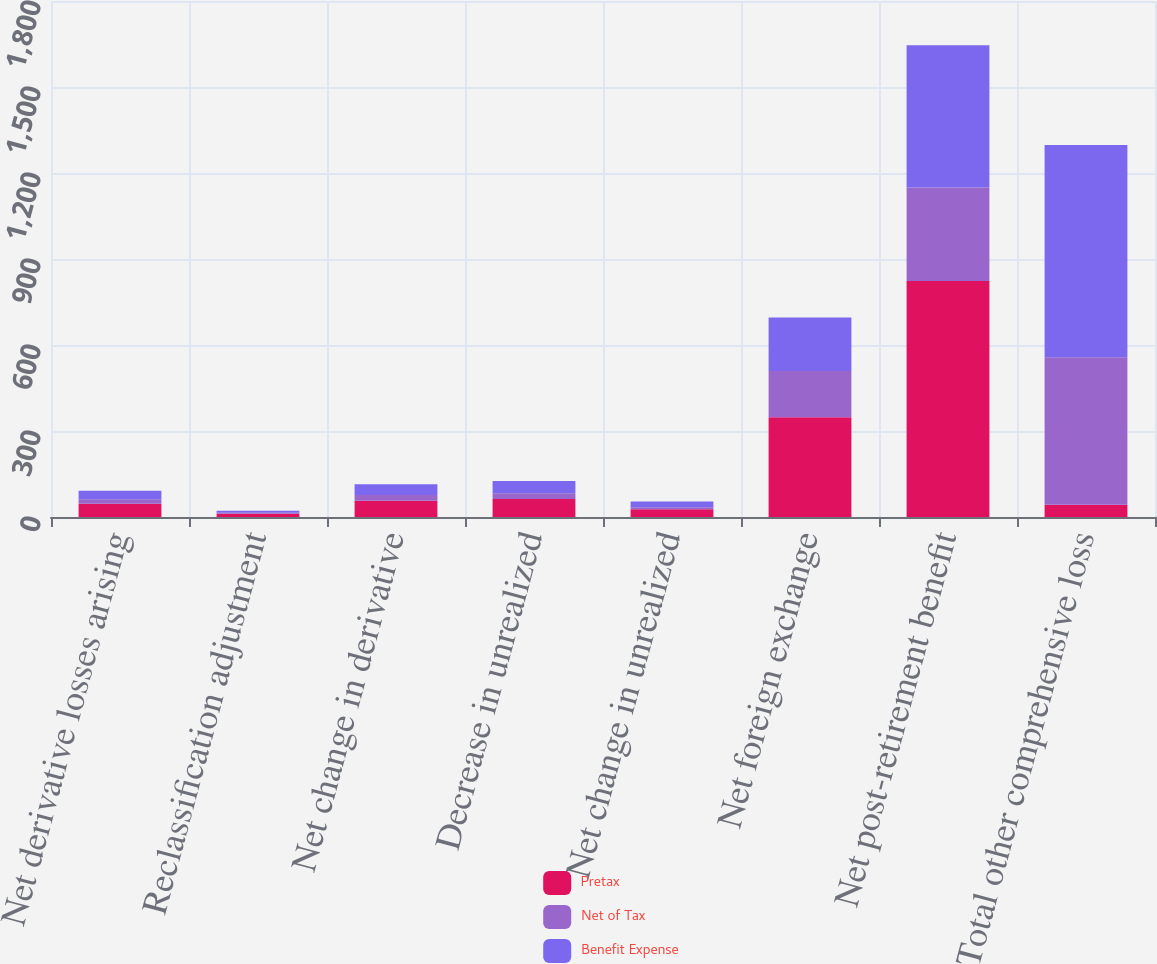<chart> <loc_0><loc_0><loc_500><loc_500><stacked_bar_chart><ecel><fcel>Net derivative losses arising<fcel>Reclassification adjustment<fcel>Net change in derivative<fcel>Decrease in unrealized<fcel>Net change in unrealized<fcel>Net foreign exchange<fcel>Net post-retirement benefit<fcel>Total other comprehensive loss<nl><fcel>Pretax<fcel>46<fcel>11<fcel>57<fcel>63<fcel>27<fcel>348<fcel>823<fcel>43<nl><fcel>Net of Tax<fcel>16<fcel>4<fcel>20<fcel>20<fcel>7<fcel>161<fcel>326<fcel>514<nl><fcel>Benefit Expense<fcel>30<fcel>7<fcel>37<fcel>43<fcel>20<fcel>187<fcel>497<fcel>741<nl></chart> 